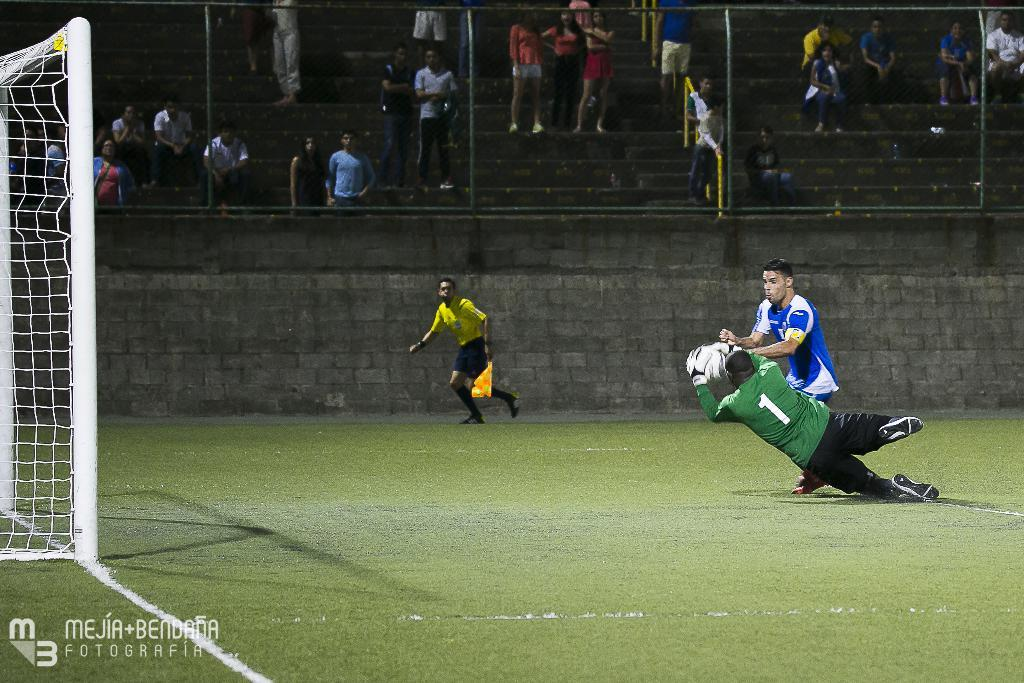<image>
Summarize the visual content of the image. A soccer player has the number one on the back of his jersey. 